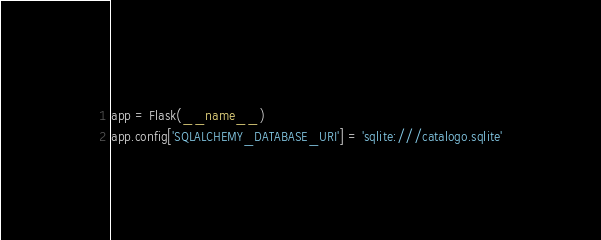Convert code to text. <code><loc_0><loc_0><loc_500><loc_500><_Python_>
app = Flask(__name__)
app.config['SQLALCHEMY_DATABASE_URI'] = 'sqlite:///catalogo.sqlite'</code> 